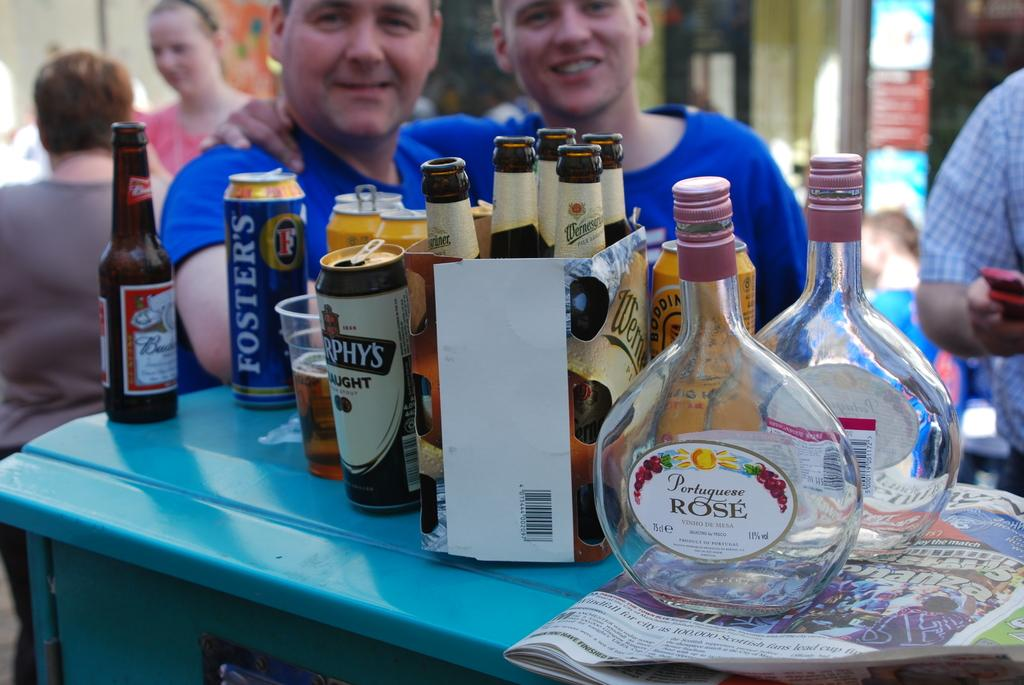<image>
Describe the image concisely. an empty bottle of portuguese rose vinho de mesa in front of another one 